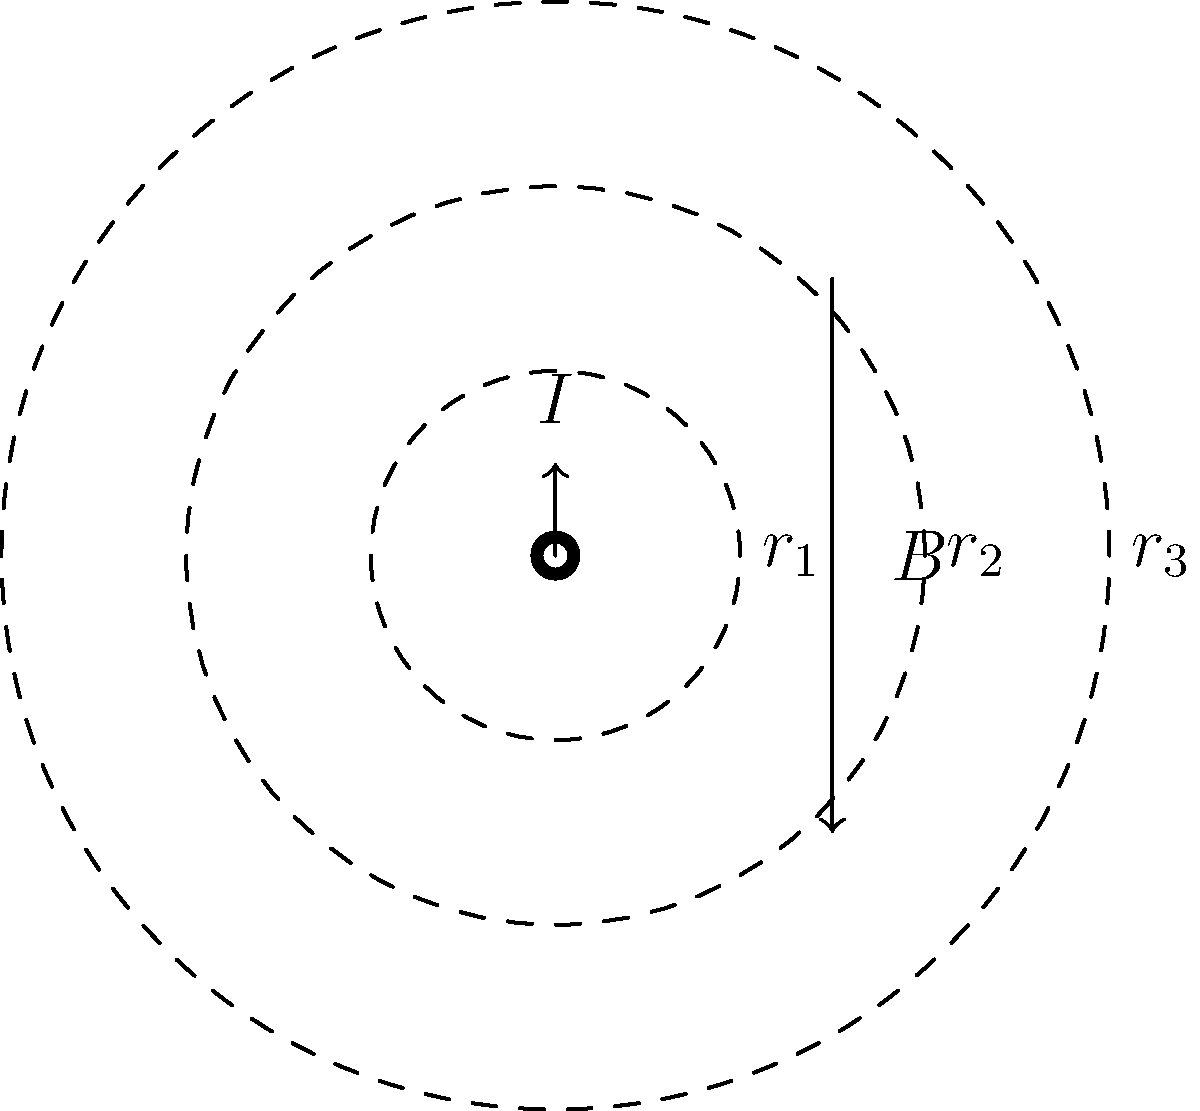As a former handball player, you understand the importance of positioning and circular movements. In a similar vein, imagine a long, straight wire carrying a current $I$. Three concentric circles with radii $r_1$, $r_2$, and $r_3$ are drawn around the wire, where $r_1 < r_2 < r_3$. If the magnetic field strength at $r_1$ is $B_1$, what is the magnetic field strength at $r_3$ in terms of $B_1$? Let's approach this step-by-step, similar to how you'd analyze a play in handball:

1) First, recall Ampère's law for the magnetic field around a straight wire:
   $B = \frac{\mu_0 I}{2\pi r}$

2) This shows that the magnetic field strength is inversely proportional to the distance from the wire.

3) We can write this relationship for any two radii as:
   $B_1 r_1 = B_2 r_2 = B_3 r_3 = \frac{\mu_0 I}{2\pi}$

4) Since we want to express $B_3$ in terms of $B_1$, let's use:
   $B_1 r_1 = B_3 r_3$

5) Rearranging this equation:
   $B_3 = B_1 \frac{r_1}{r_3}$

6) This is our final answer. It shows that the magnetic field at $r_3$ is weaker than at $r_1$ by a factor of $\frac{r_1}{r_3}$.

This relationship is similar to how the intensity of a handball throw decreases as it travels further from the thrower.
Answer: $B_3 = B_1 \frac{r_1}{r_3}$ 